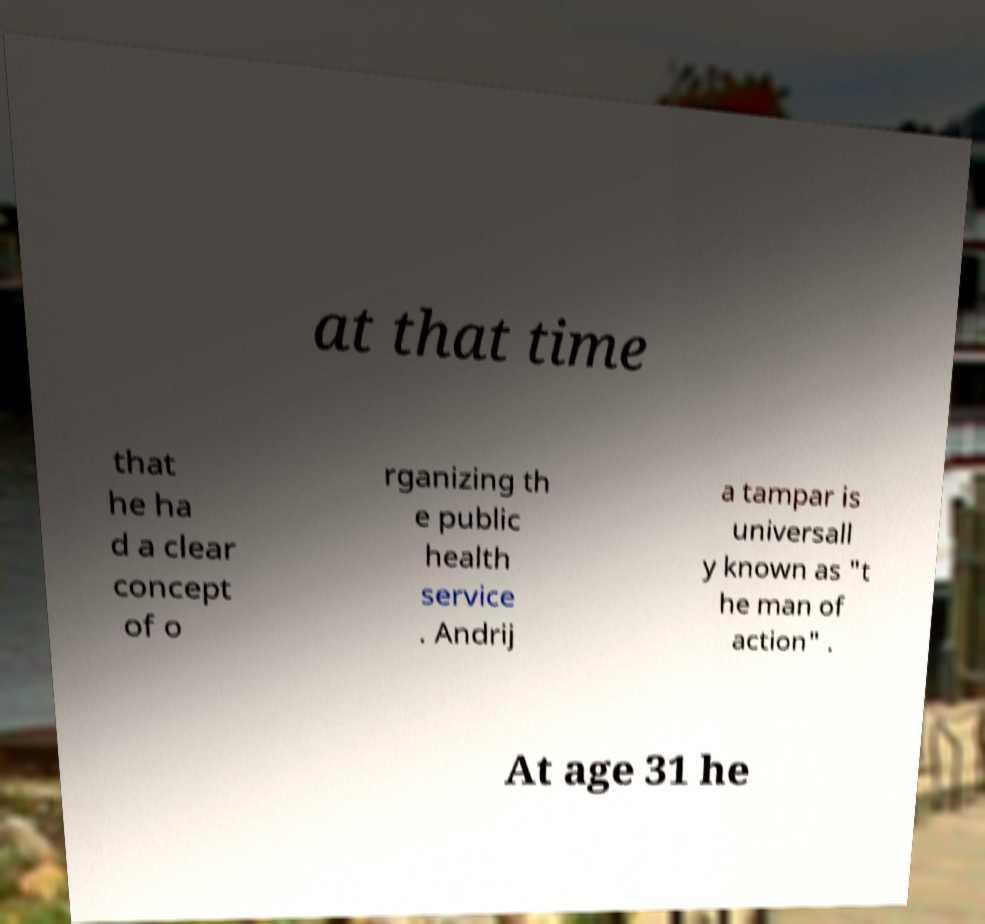Could you assist in decoding the text presented in this image and type it out clearly? at that time that he ha d a clear concept of o rganizing th e public health service . Andrij a tampar is universall y known as "t he man of action" . At age 31 he 